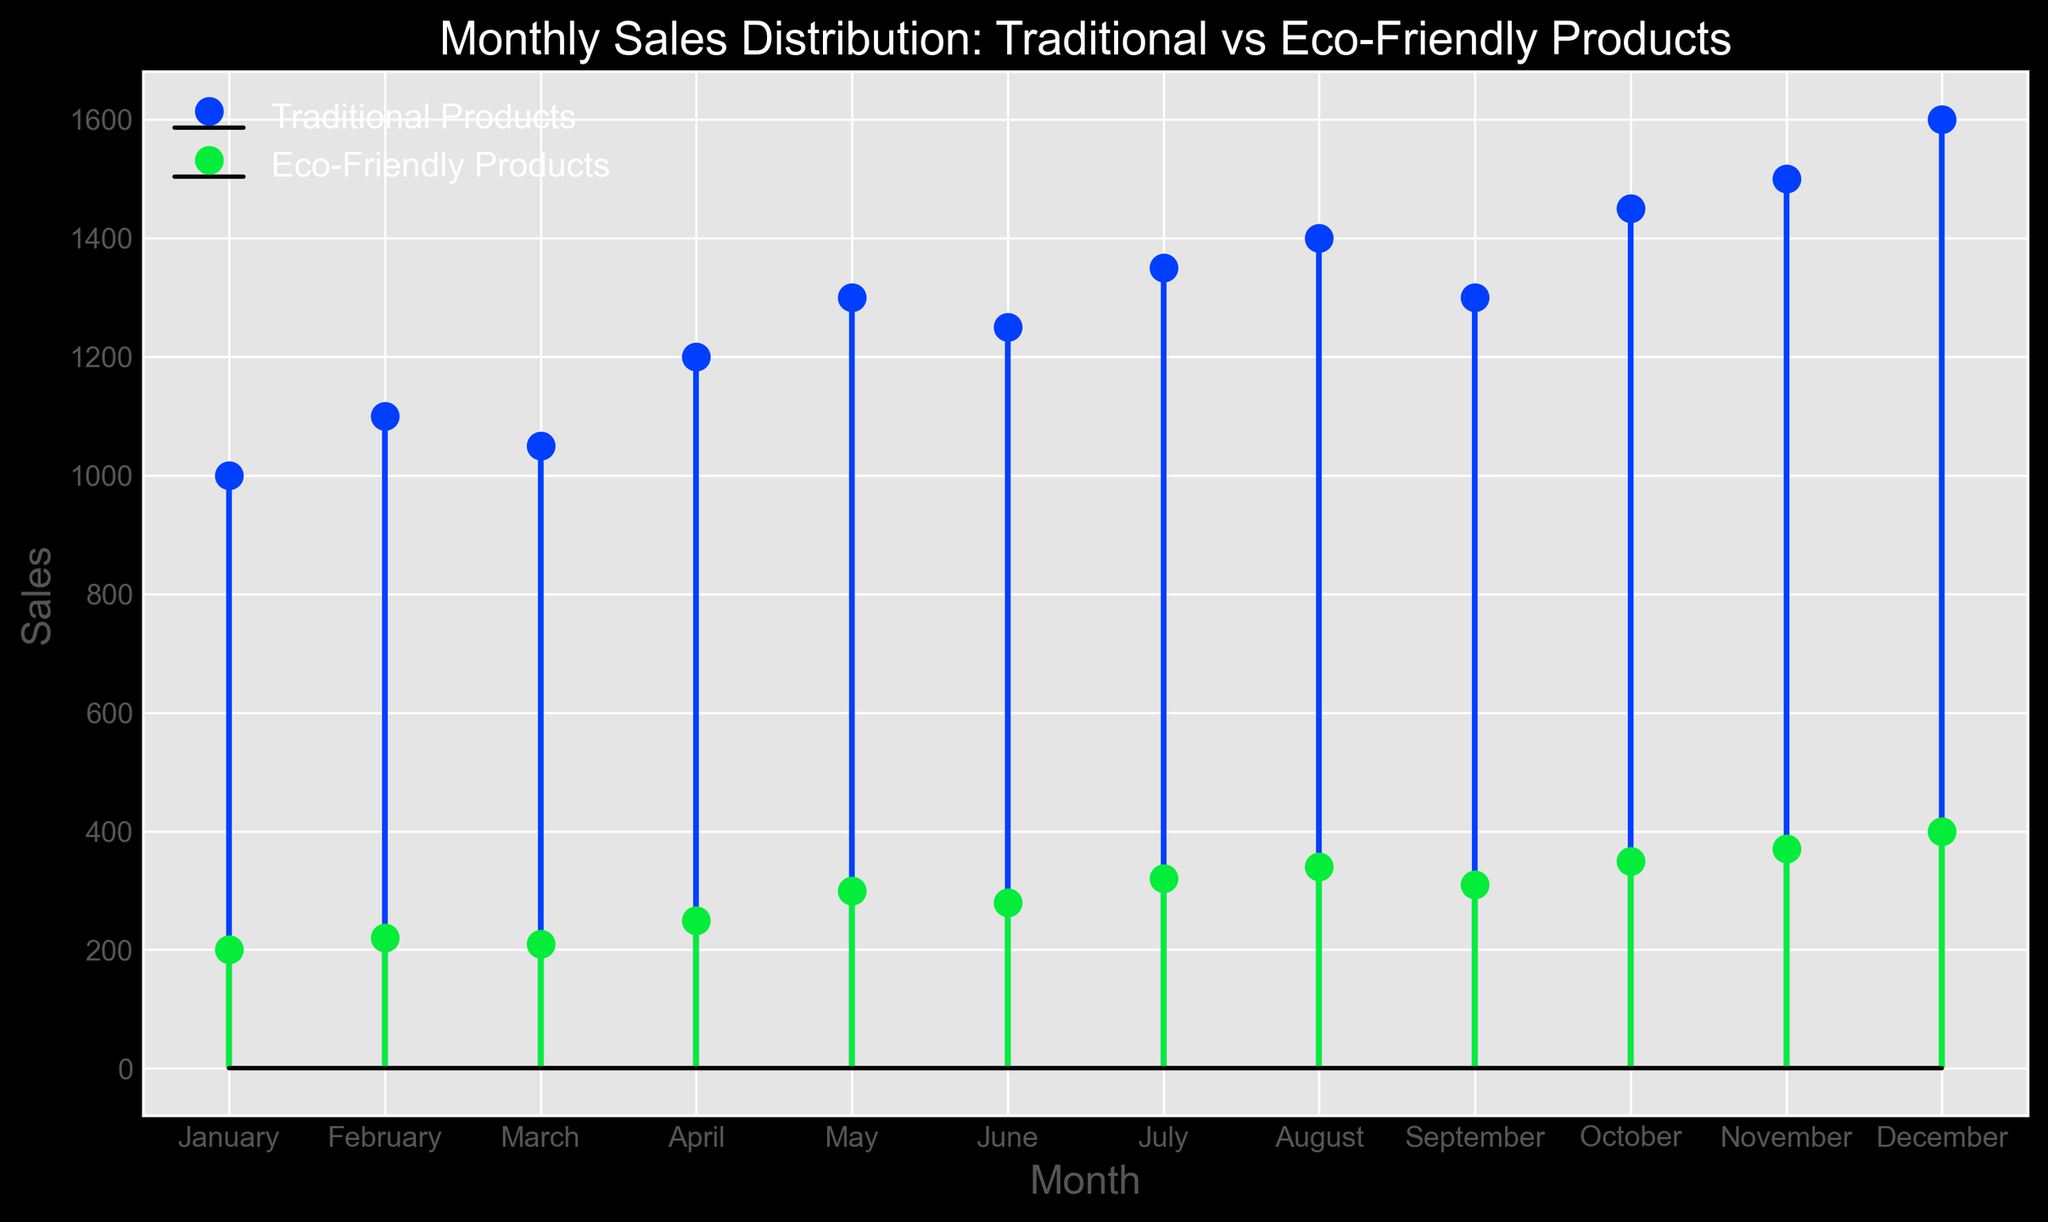What is the total sales for traditional products in the first half of the year? To find the total sales for traditional products in the first half of the year, sum the sales from January to June: 1000 + 1100 + 1050 + 1200 + 1300 + 1250 = 6900
Answer: 6900 What is the difference in sales between traditional products and eco-friendly products in December? Subtract the sales of eco-friendly products from the sales of traditional products in December: 1600 - 400 = 1200
Answer: 1200 Which product type had higher sales in August, and by how much? Compare the sales of traditional products and eco-friendly products in August: 1400 - 340 = 1060. Traditional products had higher sales.
Answer: Traditional products, 1060 In which month did eco-friendly products see the highest sales? Identify the month with the highest sales value for eco-friendly products: October (350)
Answer: October How did the sales of traditional products change from January to July? Calculate the difference in sales of traditional products between January and July: 1350 - 1000 = 350
Answer: Increased by 350 What's the average monthly sales for eco-friendly products in the second half of the year? Sum the sales of eco-friendly products from July to December and divide by 6: (320 + 340 + 310 + 350 + 370 + 400)/6 = 348.33
Answer: 348.33 In which month is the gap between traditional and eco-friendly product sales the smallest? Calculate the difference for each month and find the month with the smallest difference: August (1400 - 340 = 1060).
Answer: August What trend do you observe in the sales of eco-friendly products over the year? Observe the sales data points for eco-friendly products from January to December: The sales steadily increase throughout the year.
Answer: Steadily increasing Which month's sales of traditional products crossed 1400 for the first time in the year? Identify the first month during which traditional products' sales crossed 1400: October (1450)
Answer: October What's the combined sales of eco-friendly and traditional products in November? Sum the sales of eco-friendly products and traditional products in November: 1500 + 370 = 1870
Answer: 1870 